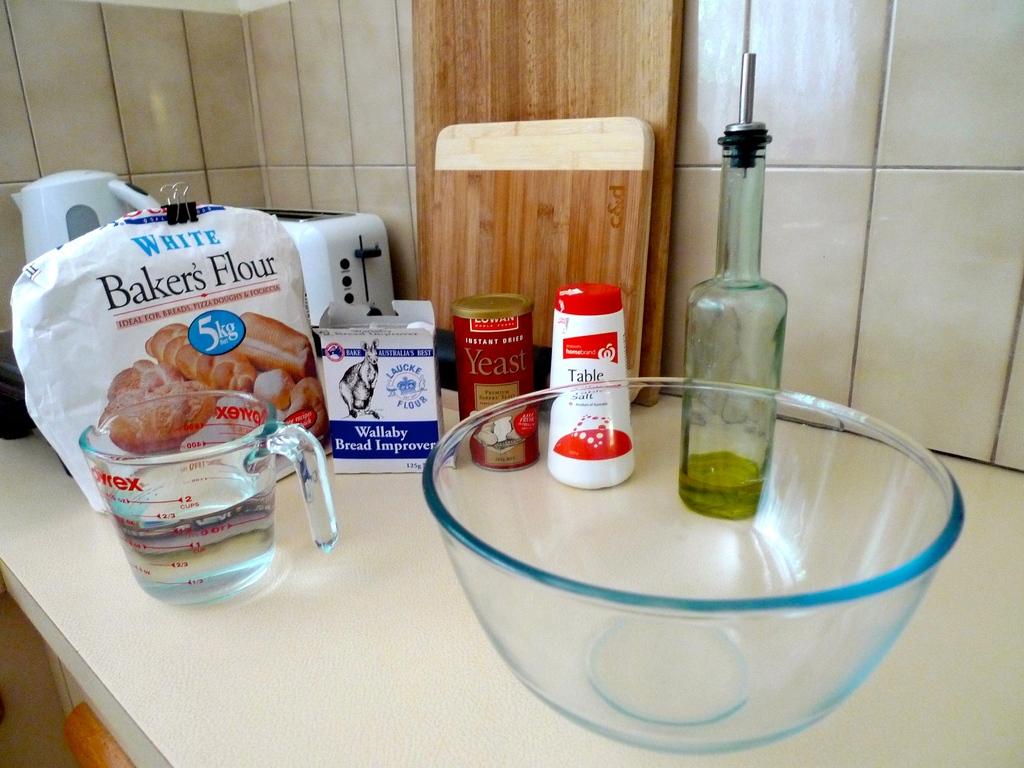What is in the red and white container?
Your response must be concise. Table salt. 